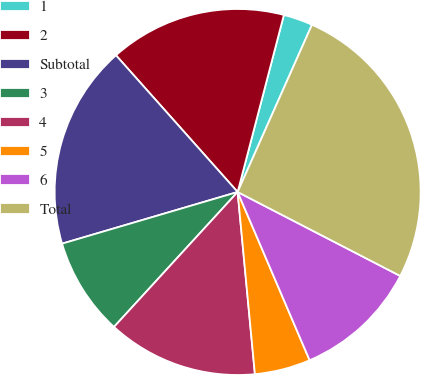<chart> <loc_0><loc_0><loc_500><loc_500><pie_chart><fcel>1<fcel>2<fcel>Subtotal<fcel>3<fcel>4<fcel>5<fcel>6<fcel>Total<nl><fcel>2.59%<fcel>15.64%<fcel>17.98%<fcel>8.64%<fcel>13.31%<fcel>4.93%<fcel>10.98%<fcel>25.93%<nl></chart> 